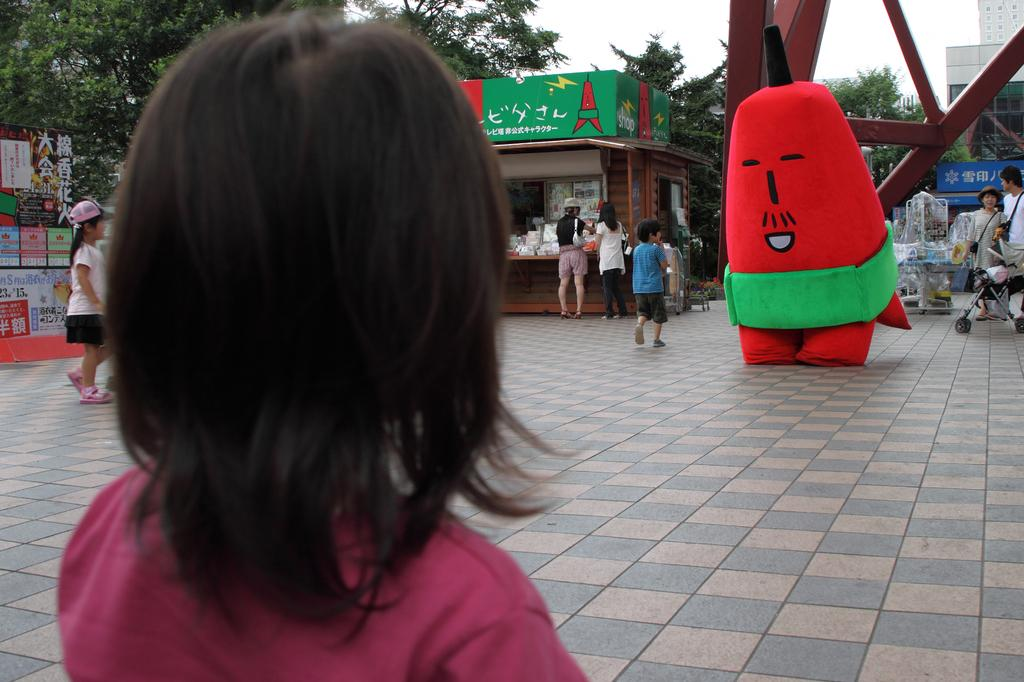What is the main subject of the image? The main subject of the image is a kid. What part of the kid's body is visible in the image? The kid's head is visible in the image. What is the kid standing in front of? The kid is standing in front of a red cartoon. Can you describe the background of the image? In the background of the image, there are many kids on the floor. What time of day is it in the image, based on the hour hand of the clock? There is no clock present in the image, so it is not possible to determine the time of day based on the hour hand. 